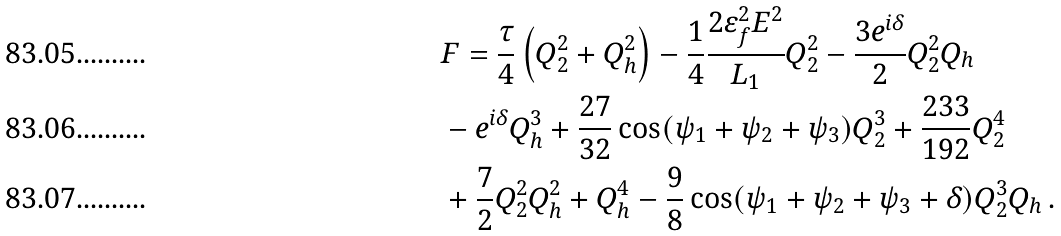<formula> <loc_0><loc_0><loc_500><loc_500>& F = \frac { \tau } { 4 } \left ( Q _ { 2 } ^ { 2 } + Q _ { h } ^ { 2 } \right ) - \frac { 1 } { 4 } \frac { 2 \varepsilon _ { f } ^ { 2 } E ^ { 2 } } { L _ { 1 } } Q _ { 2 } ^ { 2 } - \frac { 3 \text {e} ^ { i \delta } } { 2 } Q _ { 2 } ^ { 2 } Q _ { h } \\ & - \text {e} ^ { i \delta } Q _ { h } ^ { 3 } + \frac { 2 7 } { 3 2 } \cos ( \psi _ { 1 } + \psi _ { 2 } + \psi _ { 3 } ) Q _ { 2 } ^ { 3 } + \frac { 2 3 3 } { 1 9 2 } Q _ { 2 } ^ { 4 } \\ & + \frac { 7 } { 2 } Q _ { 2 } ^ { 2 } Q _ { h } ^ { 2 } + Q _ { h } ^ { 4 } - \frac { 9 } { 8 } \cos ( \psi _ { 1 } + \psi _ { 2 } + \psi _ { 3 } + \delta ) Q _ { 2 } ^ { 3 } Q _ { h } \, .</formula> 